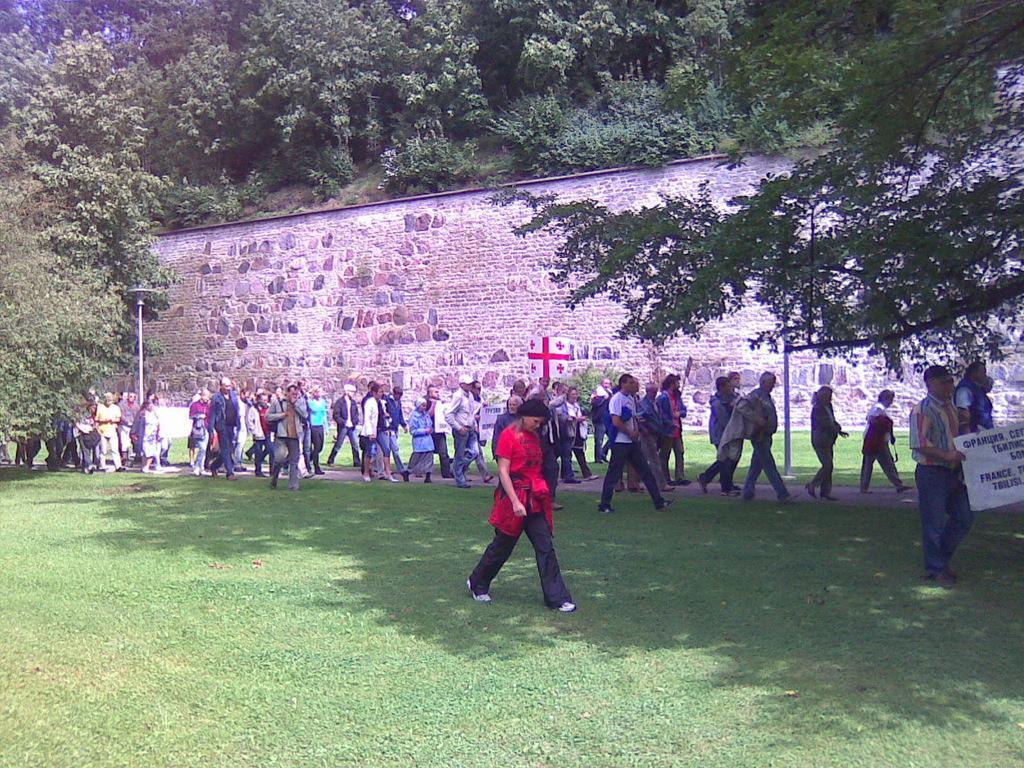How would you summarize this image in a sentence or two? In this image I can see group of people walking, I can also see a board in white color, background I can see a wall, and trees in green color. 